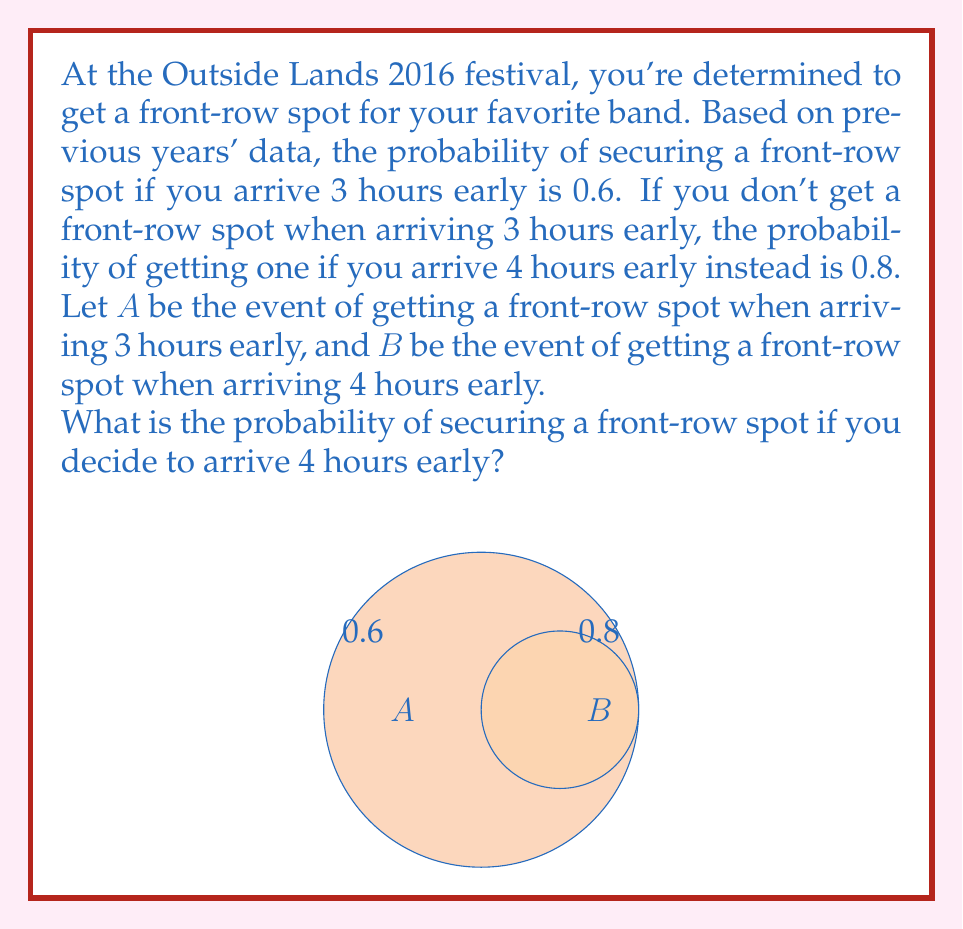Can you solve this math problem? Let's approach this step-by-step using Bayesian probability:

1) We're given:
   $P(A) = 0.6$ (probability of front-row spot arriving 3 hours early)
   $P(B|A^c) = 0.8$ (probability of front-row spot arriving 4 hours early, given no spot at 3 hours)

2) We need to find $P(B)$, which can be calculated using the law of total probability:

   $P(B) = P(B|A)P(A) + P(B|A^c)P(A^c)$

3) We know $P(A)$ and $P(A^c)$:
   $P(A) = 0.6$
   $P(A^c) = 1 - P(A) = 0.4$

4) We're given $P(B|A^c) = 0.8$, but we need to determine $P(B|A)$:
   If you got a front-row spot at 3 hours, you'll definitely have one at 4 hours.
   So, $P(B|A) = 1$

5) Now we can plug these values into our equation:

   $P(B) = P(B|A)P(A) + P(B|A^c)P(A^c)$
   $P(B) = (1)(0.6) + (0.8)(0.4)$
   $P(B) = 0.6 + 0.32$
   $P(B) = 0.92$

Therefore, the probability of securing a front-row spot if you arrive 4 hours early is 0.92 or 92%.
Answer: 0.92 